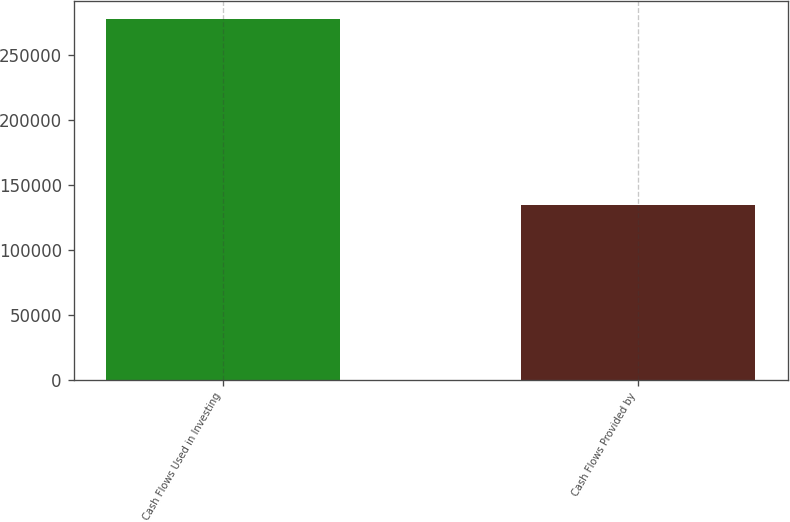Convert chart. <chart><loc_0><loc_0><loc_500><loc_500><bar_chart><fcel>Cash Flows Used in Investing<fcel>Cash Flows Provided by<nl><fcel>278136<fcel>134901<nl></chart> 